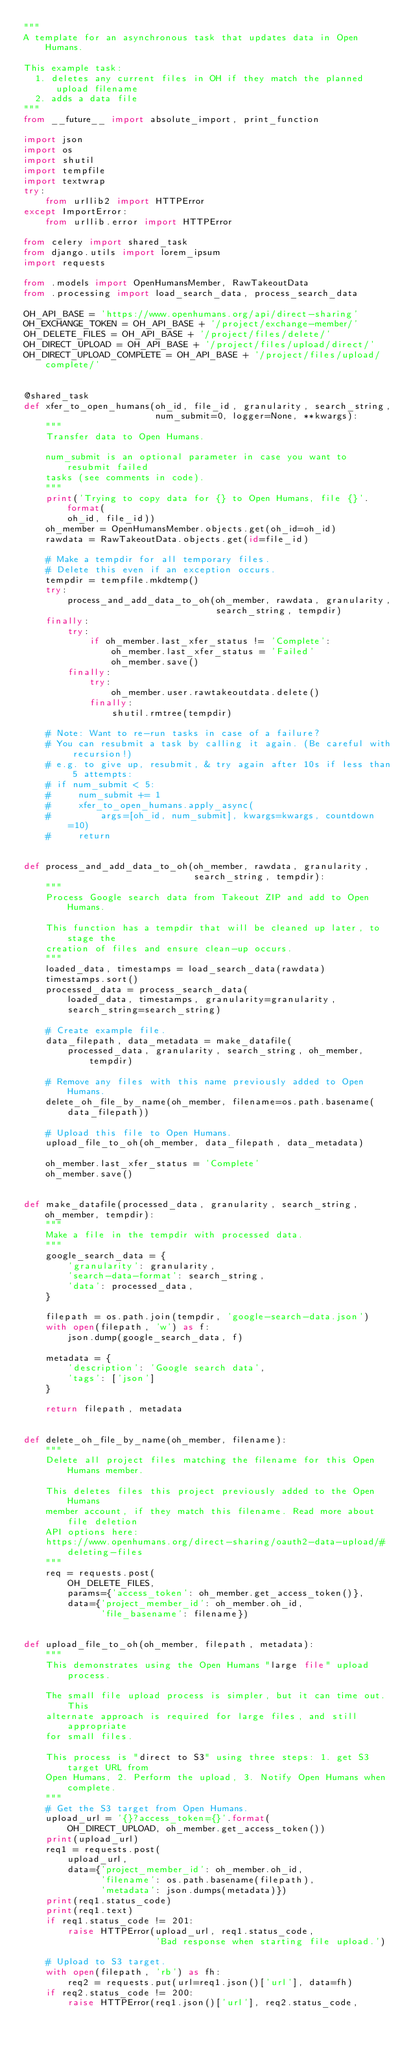<code> <loc_0><loc_0><loc_500><loc_500><_Python_>"""
A template for an asynchronous task that updates data in Open Humans.

This example task:
  1. deletes any current files in OH if they match the planned upload filename
  2. adds a data file
"""
from __future__ import absolute_import, print_function

import json
import os
import shutil
import tempfile
import textwrap
try:
    from urllib2 import HTTPError
except ImportError:
    from urllib.error import HTTPError

from celery import shared_task
from django.utils import lorem_ipsum
import requests

from .models import OpenHumansMember, RawTakeoutData
from .processing import load_search_data, process_search_data

OH_API_BASE = 'https://www.openhumans.org/api/direct-sharing'
OH_EXCHANGE_TOKEN = OH_API_BASE + '/project/exchange-member/'
OH_DELETE_FILES = OH_API_BASE + '/project/files/delete/'
OH_DIRECT_UPLOAD = OH_API_BASE + '/project/files/upload/direct/'
OH_DIRECT_UPLOAD_COMPLETE = OH_API_BASE + '/project/files/upload/complete/'


@shared_task
def xfer_to_open_humans(oh_id, file_id, granularity, search_string,
                        num_submit=0, logger=None, **kwargs):
    """
    Transfer data to Open Humans.

    num_submit is an optional parameter in case you want to resubmit failed
    tasks (see comments in code).
    """
    print('Trying to copy data for {} to Open Humans, file {}'.format(
        oh_id, file_id))
    oh_member = OpenHumansMember.objects.get(oh_id=oh_id)
    rawdata = RawTakeoutData.objects.get(id=file_id)

    # Make a tempdir for all temporary files.
    # Delete this even if an exception occurs.
    tempdir = tempfile.mkdtemp()
    try:
        process_and_add_data_to_oh(oh_member, rawdata, granularity,
                                   search_string, tempdir)
    finally:
        try:
            if oh_member.last_xfer_status != 'Complete':
                oh_member.last_xfer_status = 'Failed'
                oh_member.save()
        finally:
            try:
                oh_member.user.rawtakeoutdata.delete()
            finally:
                shutil.rmtree(tempdir)

    # Note: Want to re-run tasks in case of a failure?
    # You can resubmit a task by calling it again. (Be careful with recursion!)
    # e.g. to give up, resubmit, & try again after 10s if less than 5 attempts:
    # if num_submit < 5:
    #     num_submit += 1
    #     xfer_to_open_humans.apply_async(
    #         args=[oh_id, num_submit], kwargs=kwargs, countdown=10)
    #     return


def process_and_add_data_to_oh(oh_member, rawdata, granularity,
                               search_string, tempdir):
    """
    Process Google search data from Takeout ZIP and add to Open Humans.

    This function has a tempdir that will be cleaned up later, to stage the
    creation of files and ensure clean-up occurs.
    """
    loaded_data, timestamps = load_search_data(rawdata)
    timestamps.sort()
    processed_data = process_search_data(
        loaded_data, timestamps, granularity=granularity,
        search_string=search_string)

    # Create example file.
    data_filepath, data_metadata = make_datafile(
        processed_data, granularity, search_string, oh_member, tempdir)

    # Remove any files with this name previously added to Open Humans.
    delete_oh_file_by_name(oh_member, filename=os.path.basename(data_filepath))

    # Upload this file to Open Humans.
    upload_file_to_oh(oh_member, data_filepath, data_metadata)

    oh_member.last_xfer_status = 'Complete'
    oh_member.save()


def make_datafile(processed_data, granularity, search_string, oh_member, tempdir):
    """
    Make a file in the tempdir with processed data.
    """
    google_search_data = {
        'granularity': granularity,
        'search-data-format': search_string,
        'data': processed_data,
    }

    filepath = os.path.join(tempdir, 'google-search-data.json')
    with open(filepath, 'w') as f:
        json.dump(google_search_data, f)

    metadata = {
        'description': 'Google search data',
        'tags': ['json']
    }

    return filepath, metadata


def delete_oh_file_by_name(oh_member, filename):
    """
    Delete all project files matching the filename for this Open Humans member.

    This deletes files this project previously added to the Open Humans
    member account, if they match this filename. Read more about file deletion
    API options here:
    https://www.openhumans.org/direct-sharing/oauth2-data-upload/#deleting-files
    """
    req = requests.post(
        OH_DELETE_FILES,
        params={'access_token': oh_member.get_access_token()},
        data={'project_member_id': oh_member.oh_id,
              'file_basename': filename})


def upload_file_to_oh(oh_member, filepath, metadata):
    """
    This demonstrates using the Open Humans "large file" upload process.

    The small file upload process is simpler, but it can time out. This
    alternate approach is required for large files, and still appropriate
    for small files.

    This process is "direct to S3" using three steps: 1. get S3 target URL from
    Open Humans, 2. Perform the upload, 3. Notify Open Humans when complete.
    """
    # Get the S3 target from Open Humans.
    upload_url = '{}?access_token={}'.format(
        OH_DIRECT_UPLOAD, oh_member.get_access_token())
    print(upload_url)
    req1 = requests.post(
        upload_url,
        data={'project_member_id': oh_member.oh_id,
              'filename': os.path.basename(filepath),
              'metadata': json.dumps(metadata)})
    print(req1.status_code)
    print(req1.text)
    if req1.status_code != 201:
        raise HTTPError(upload_url, req1.status_code,
                        'Bad response when starting file upload.')

    # Upload to S3 target.
    with open(filepath, 'rb') as fh:
        req2 = requests.put(url=req1.json()['url'], data=fh)
    if req2.status_code != 200:
        raise HTTPError(req1.json()['url'], req2.status_code,</code> 